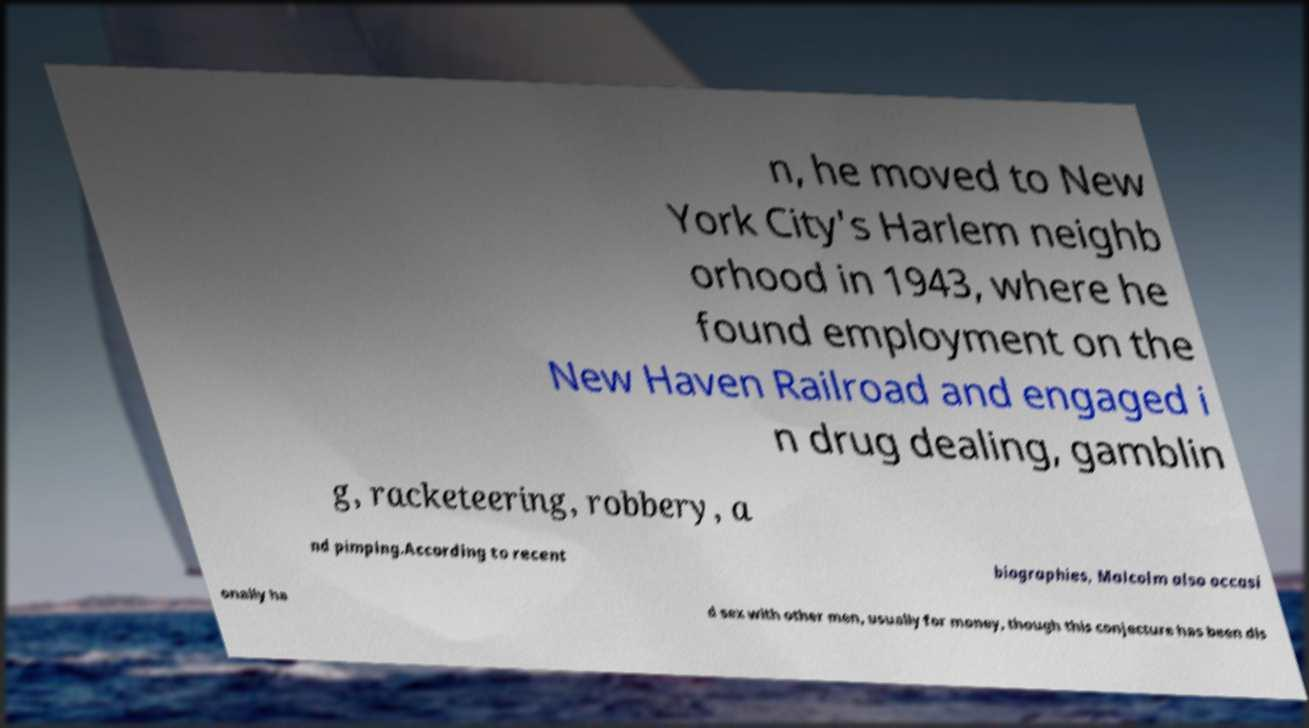There's text embedded in this image that I need extracted. Can you transcribe it verbatim? n, he moved to New York City's Harlem neighb orhood in 1943, where he found employment on the New Haven Railroad and engaged i n drug dealing, gamblin g, racketeering, robbery, a nd pimping.According to recent biographies, Malcolm also occasi onally ha d sex with other men, usually for money, though this conjecture has been dis 